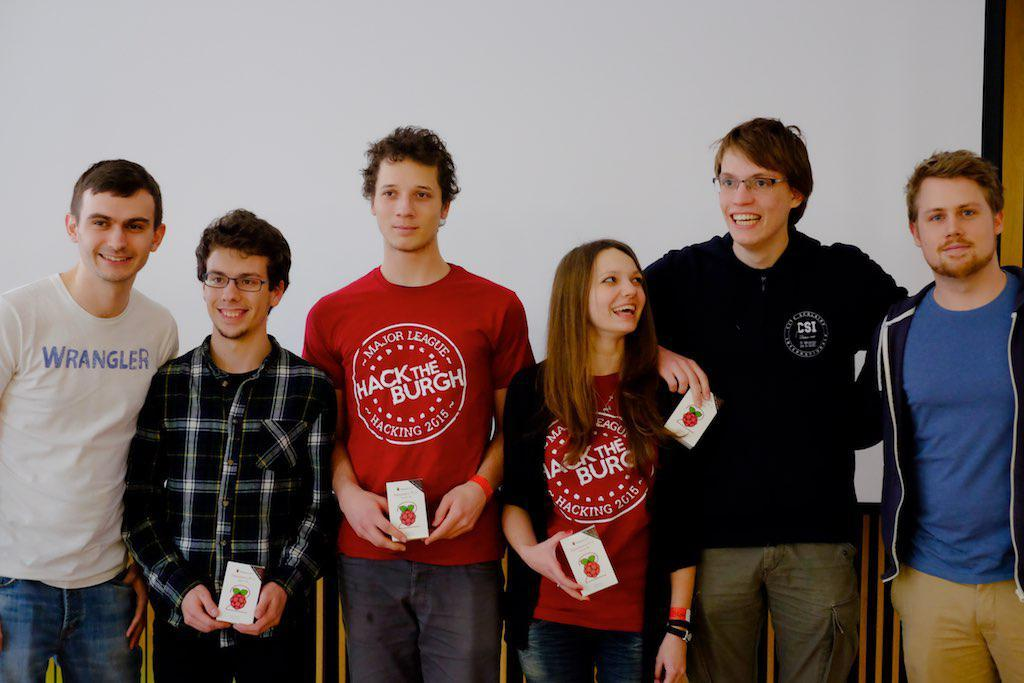Provide a one-sentence caption for the provided image. Two of the six people in the picture are wearing Hack The Burgh t-shirts. 